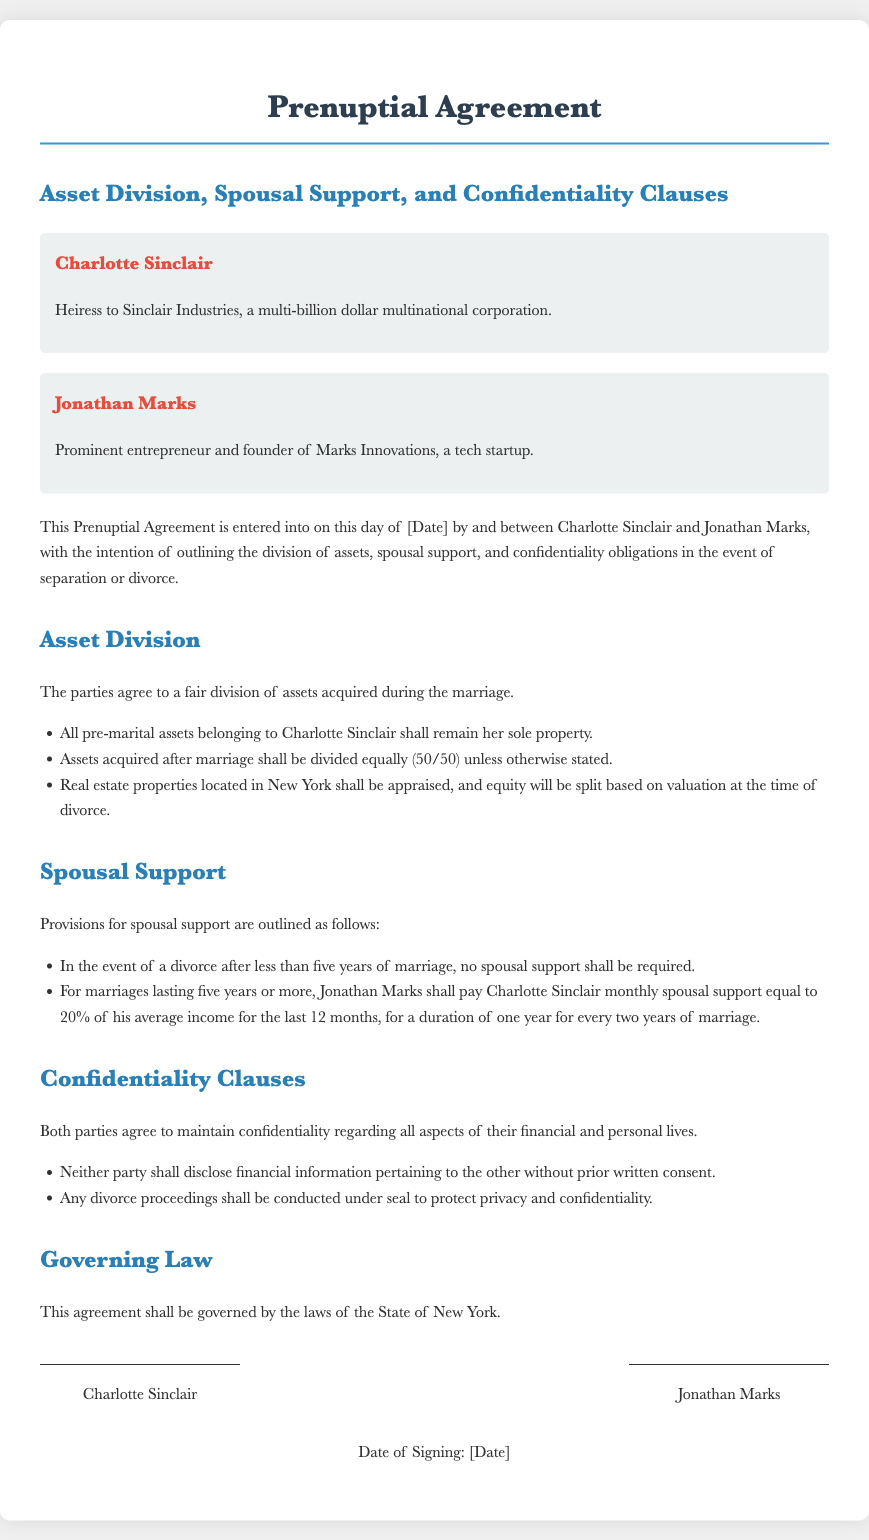What is the name of the heiress? The document identifies the heiress as Charlotte Sinclair.
Answer: Charlotte Sinclair Who is the founder of Marks Innovations? The document states that Jonathan Marks is the founder of Marks Innovations.
Answer: Jonathan Marks What percentage of his average income must Jonathan pay Charlotte after five years of marriage? The document indicates that Jonathan Marks shall pay Charlotte Sinclair 20% of his average income.
Answer: 20% What is the division ratio for assets acquired after marriage? The document specifies that assets acquired after marriage shall be divided equally, or 50/50.
Answer: 50/50 What clause requires parties to maintain confidentiality? The document includes a section on confidentiality clauses, which requires both parties to maintain confidentiality.
Answer: Confidentiality clauses In how many years of marriage must spousal support be provided? The document indicates that spousal support is required for marriages lasting five years or more.
Answer: five years What type of law governs this agreement? The document states that this agreement shall be governed by the laws of the State of New York.
Answer: State of New York Are divorce proceedings to be disclosed publicly? The document states that any divorce proceedings shall be conducted under seal to protect privacy and confidentiality.
Answer: No What happens to Charlotte's pre-marital assets? The document specifies that all pre-marital assets belonging to Charlotte Sinclair shall remain her sole property.
Answer: Remain her sole property 